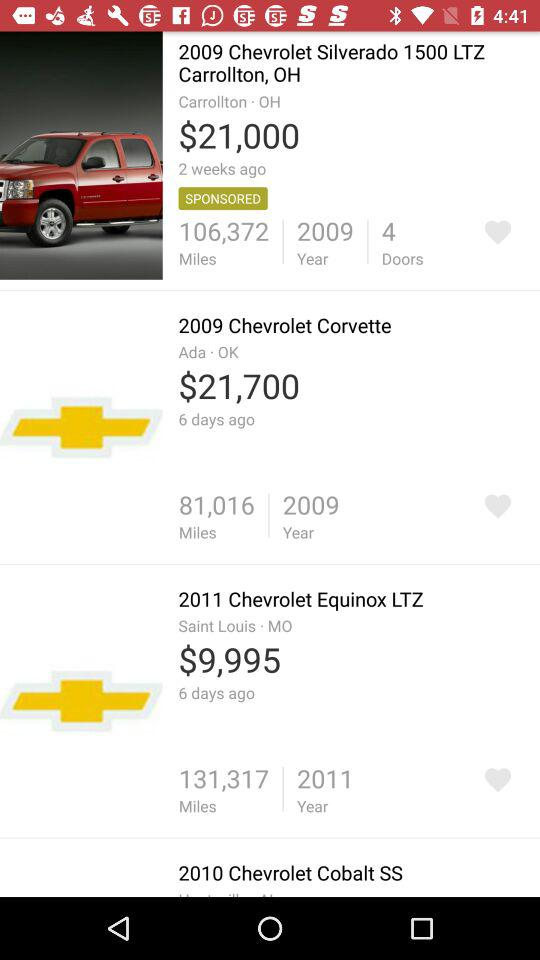What is the cost of the 2009 Chevrolet Corvette? The cost is $21,700. 